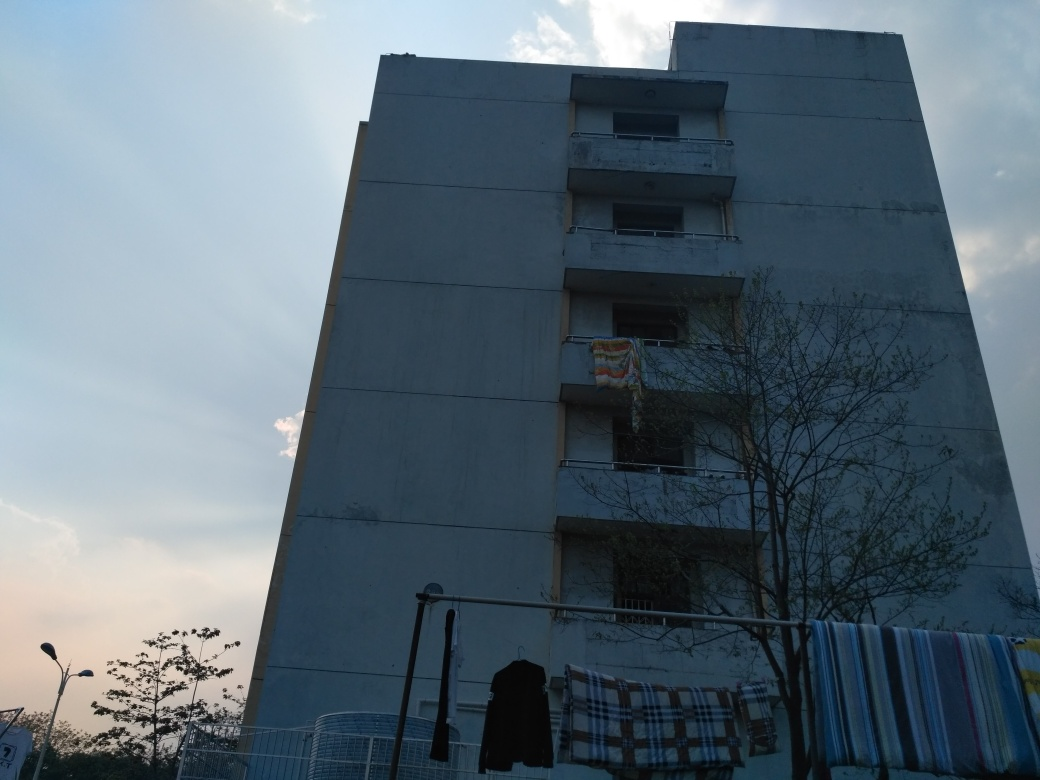Is the brightness relatively dark? The brightness in the image is indeed on the lower side, which may be due to the time of day being either dawn or dusk, creating long shadows and a dimmer ambient light. This effect is further emphasized by the building's position, which does not seem to receive direct sunlight and the cloudy sky which diffuses the natural light. 